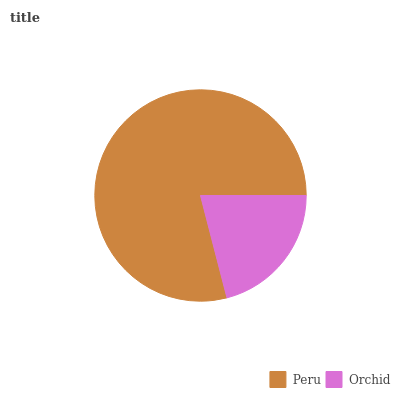Is Orchid the minimum?
Answer yes or no. Yes. Is Peru the maximum?
Answer yes or no. Yes. Is Orchid the maximum?
Answer yes or no. No. Is Peru greater than Orchid?
Answer yes or no. Yes. Is Orchid less than Peru?
Answer yes or no. Yes. Is Orchid greater than Peru?
Answer yes or no. No. Is Peru less than Orchid?
Answer yes or no. No. Is Peru the high median?
Answer yes or no. Yes. Is Orchid the low median?
Answer yes or no. Yes. Is Orchid the high median?
Answer yes or no. No. Is Peru the low median?
Answer yes or no. No. 